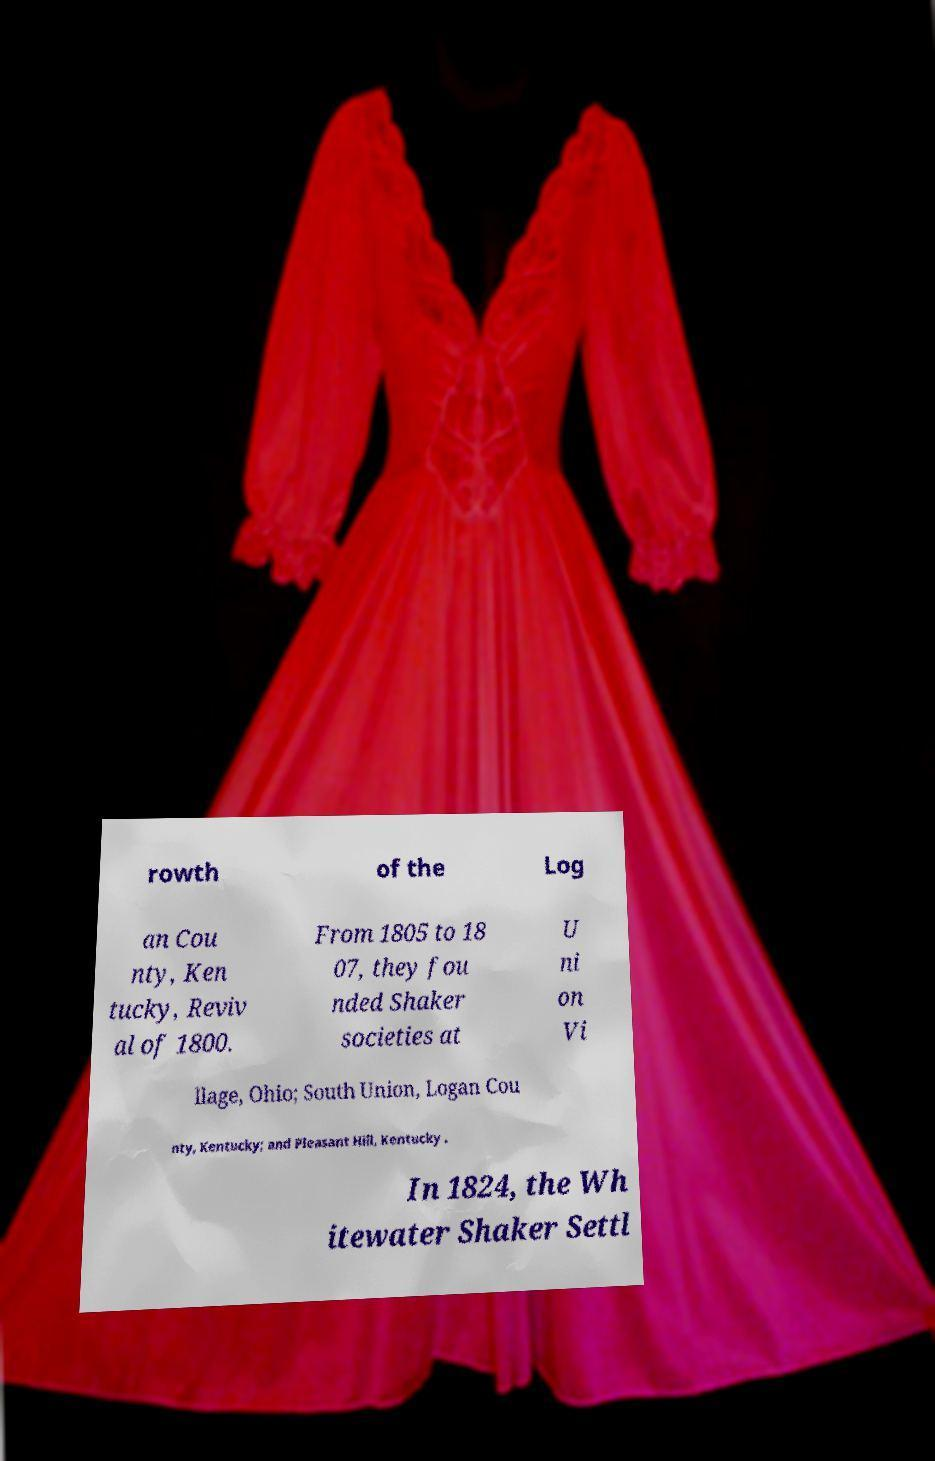What messages or text are displayed in this image? I need them in a readable, typed format. rowth of the Log an Cou nty, Ken tucky, Reviv al of 1800. From 1805 to 18 07, they fou nded Shaker societies at U ni on Vi llage, Ohio; South Union, Logan Cou nty, Kentucky; and Pleasant Hill, Kentucky . In 1824, the Wh itewater Shaker Settl 